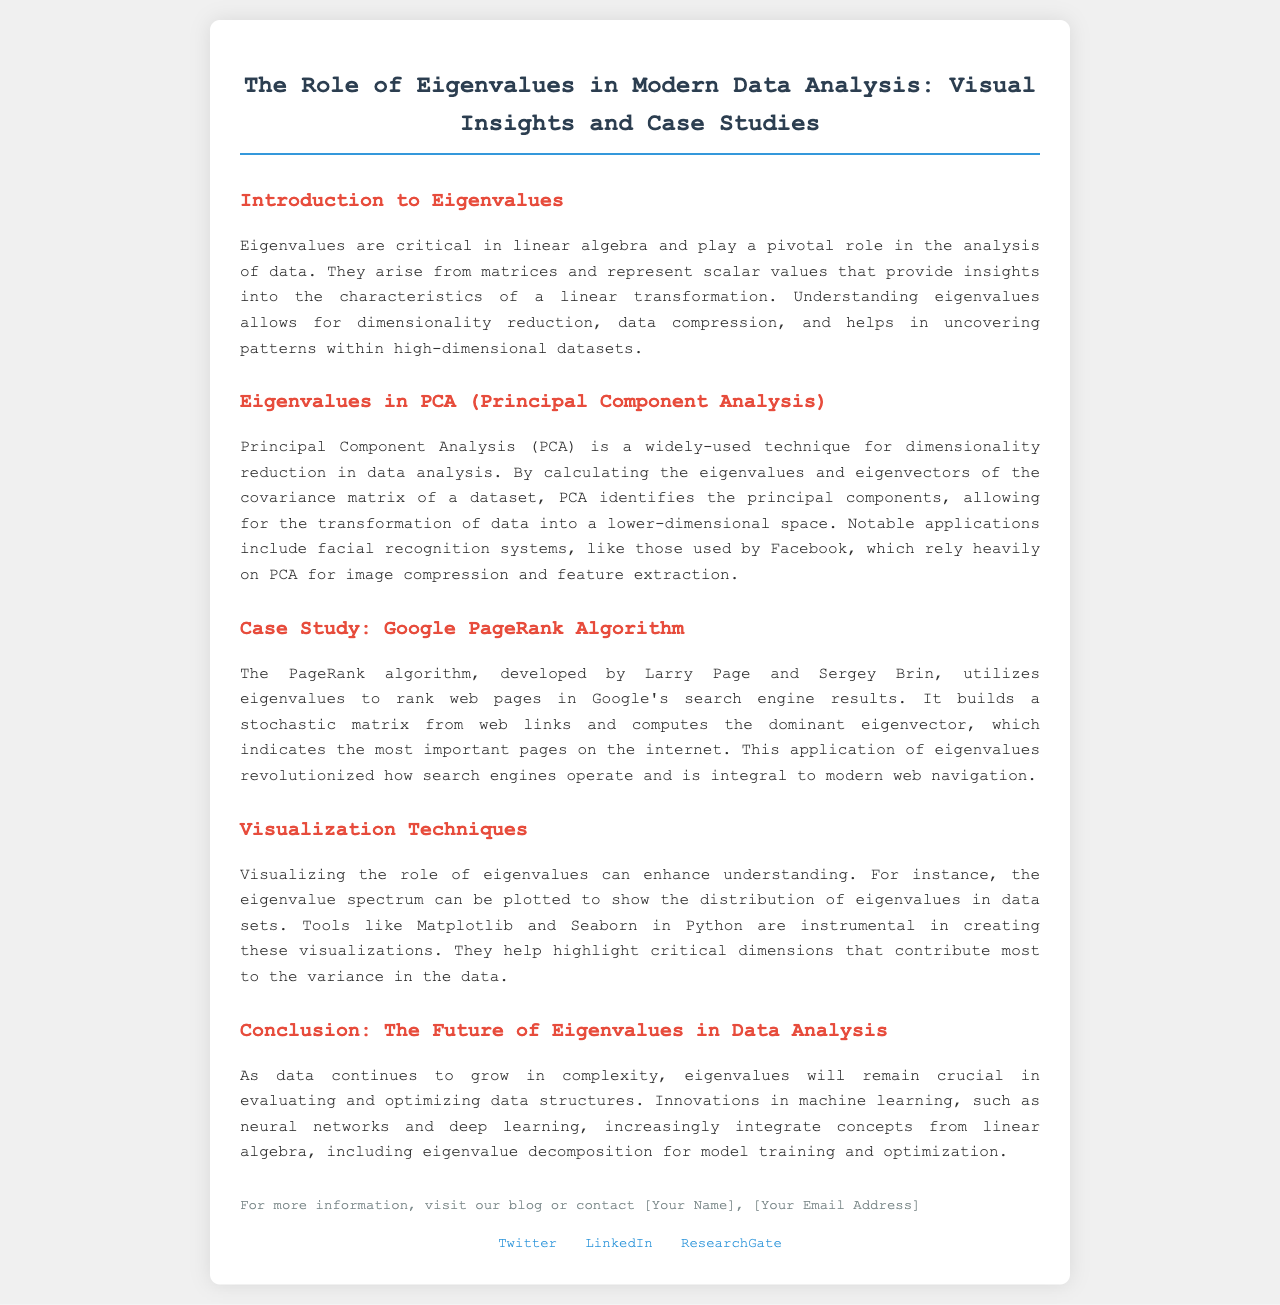What is the title of the brochure? The title is stated at the top of the document.
Answer: The Role of Eigenvalues in Modern Data Analysis: Visual Insights and Case Studies What does PCA stand for? PCA is referred to in the section on Eigenvalues in PCA.
Answer: Principal Component Analysis Who developed the PageRank algorithm? The document notes the creators of the PageRank algorithm in the case study section.
Answer: Larry Page and Sergey Brin Which tools are mentioned for visualization? The visualization techniques section lists specific tools used for plotting.
Answer: Matplotlib and Seaborn What key application of PCA is highlighted? The primary application of PCA is noted in the relevant section of the brochure.
Answer: Facial recognition systems What is emphasized in the conclusion about the future of eigenvalues? The conclusion discusses the ongoing relevance of eigenvalues in a specific context.
Answer: Evaluating and optimizing data structures In which year is the data analysis considered to grow in complexity? The conclusion refers to the ongoing challenge in data analysis as it evolves.
Answer: N/A (Focuses on "as data continues to grow") What element from linear algebra is increasingly integrated into innovations in machine learning? The conclusion states what aspect of linear algebra is being utilized in modern applications.
Answer: Eigenvalue decomposition 